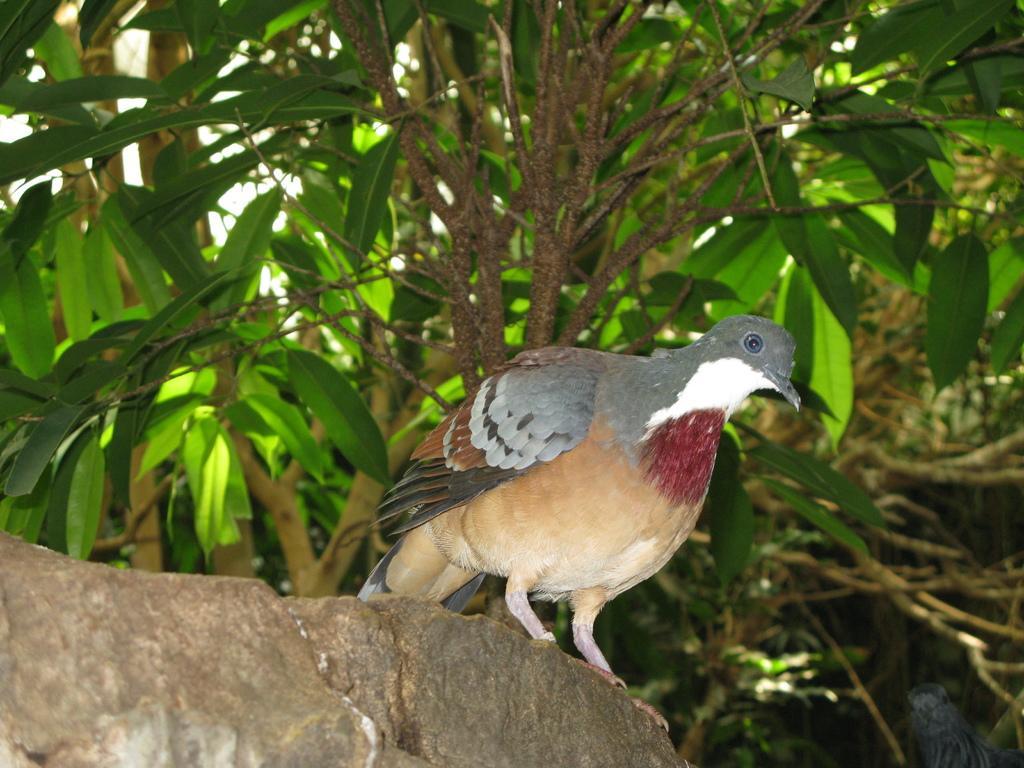Describe this image in one or two sentences. In front of the image there is a bird on the rock. Beside the rock there is another bird. In the background of the image there are trees. 